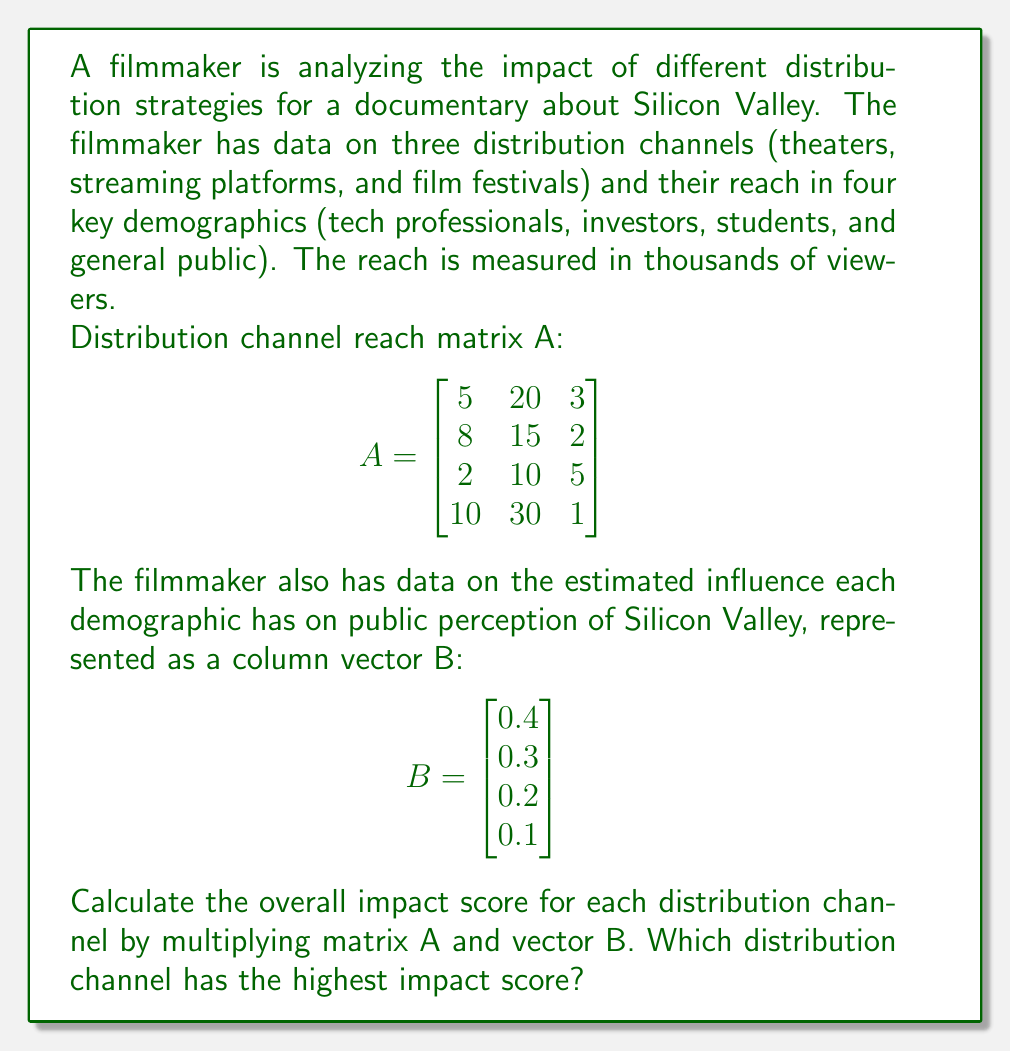Help me with this question. To solve this problem, we need to perform matrix multiplication of A and B. The resulting vector will give us the impact score for each distribution channel.

Step 1: Set up the matrix multiplication
$$AB = \begin{bmatrix}
5 & 20 & 3 \\
8 & 15 & 2 \\
2 & 10 & 5 \\
10 & 30 & 1
\end{bmatrix} \begin{bmatrix}
0.4 \\
0.3 \\
0.2 \\
0.1
\end{bmatrix}$$

Step 2: Multiply each row of A by B
For the first row (theaters):
$$(5 \times 0.4) + (20 \times 0.3) + (3 \times 0.2) + (10 \times 0.1) = 2 + 6 + 0.6 + 1 = 9.6$$

For the second row (streaming platforms):
$$(8 \times 0.4) + (15 \times 0.3) + (2 \times 0.2) + (30 \times 0.1) = 3.2 + 4.5 + 0.4 + 3 = 11.1$$

For the third row (film festivals):
$$(2 \times 0.4) + (10 \times 0.3) + (5 \times 0.2) + (1 \times 0.1) = 0.8 + 3 + 1 + 0.1 = 4.9$$

Step 3: Write the result as a column vector
$$AB = \begin{bmatrix}
9.6 \\
11.1 \\
4.9
\end{bmatrix}$$

Step 4: Identify the highest impact score
The highest impact score is 11.1, which corresponds to streaming platforms.
Answer: Streaming platforms (11.1) 